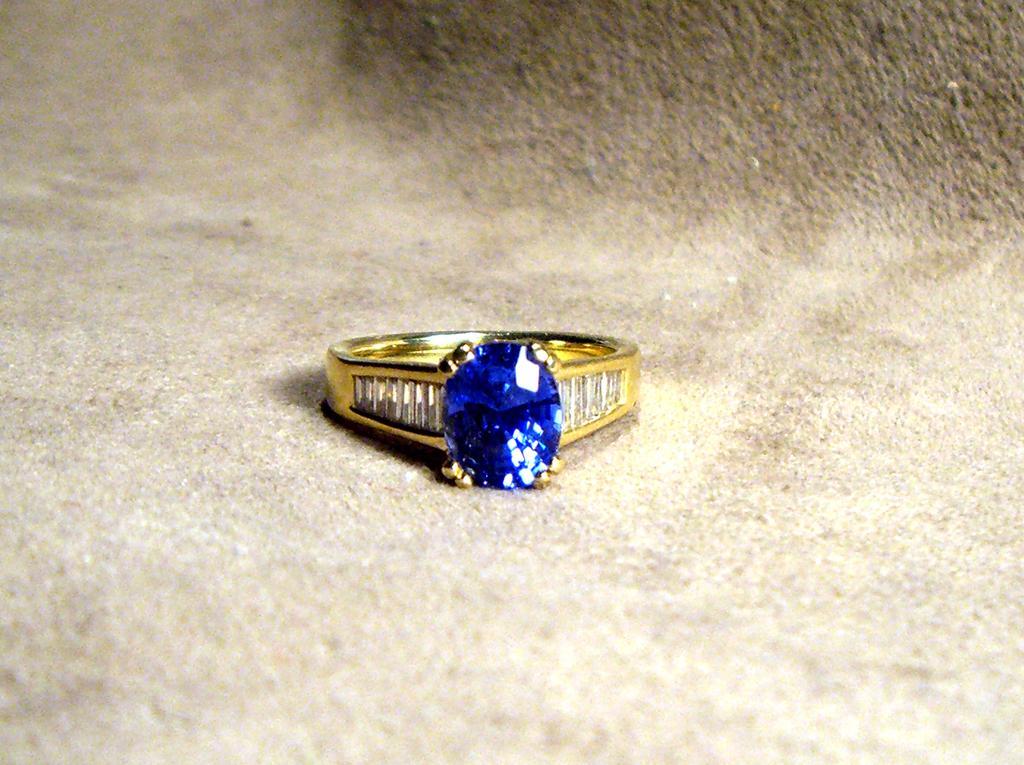Could you give a brief overview of what you see in this image? In this picture we can see a gold ring with a blue stone kept on the ground. 